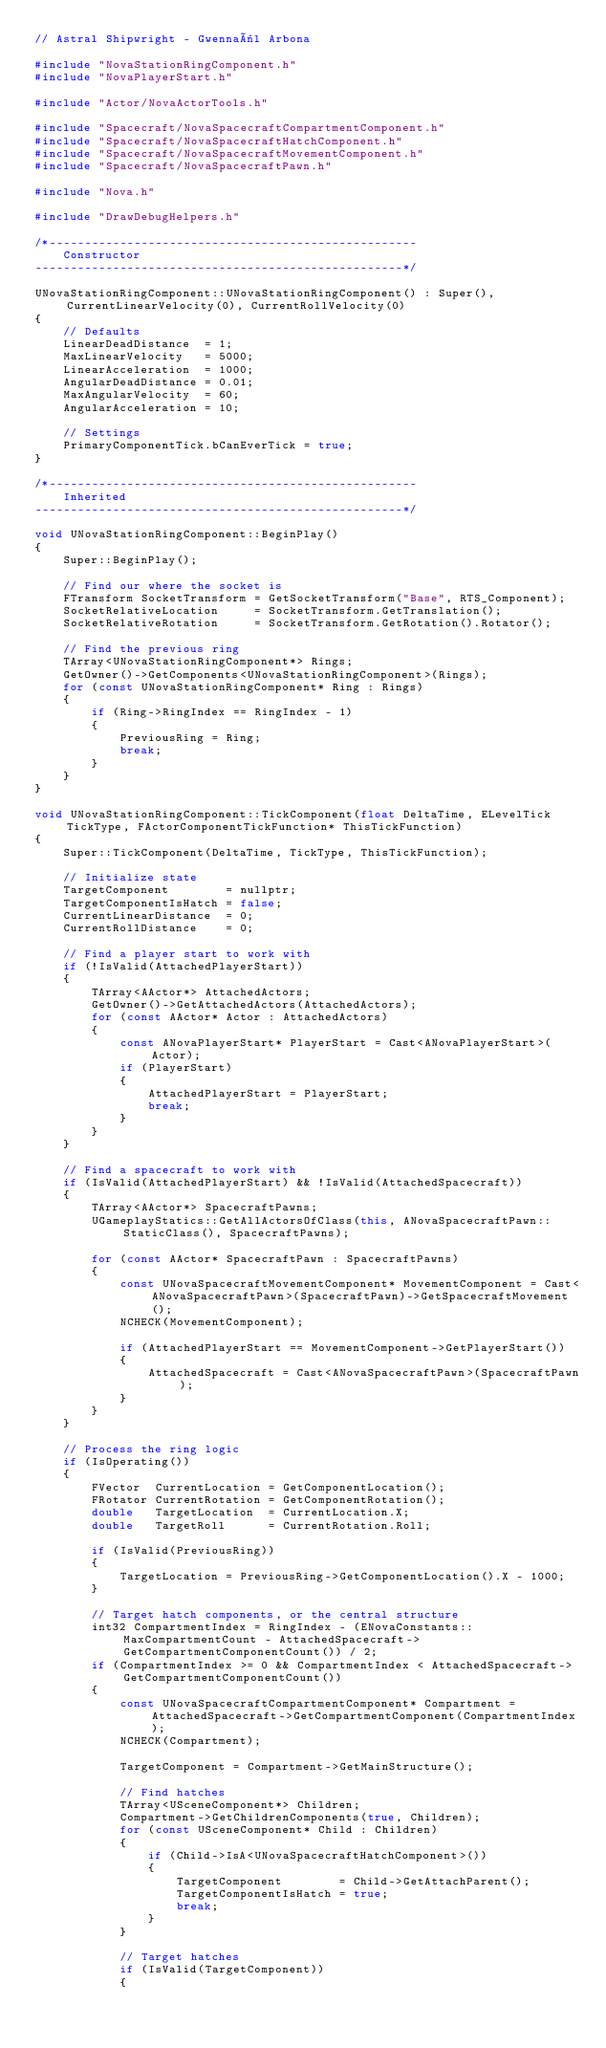Convert code to text. <code><loc_0><loc_0><loc_500><loc_500><_C++_>// Astral Shipwright - Gwennaël Arbona

#include "NovaStationRingComponent.h"
#include "NovaPlayerStart.h"

#include "Actor/NovaActorTools.h"

#include "Spacecraft/NovaSpacecraftCompartmentComponent.h"
#include "Spacecraft/NovaSpacecraftHatchComponent.h"
#include "Spacecraft/NovaSpacecraftMovementComponent.h"
#include "Spacecraft/NovaSpacecraftPawn.h"

#include "Nova.h"

#include "DrawDebugHelpers.h"

/*----------------------------------------------------
    Constructor
----------------------------------------------------*/

UNovaStationRingComponent::UNovaStationRingComponent() : Super(), CurrentLinearVelocity(0), CurrentRollVelocity(0)
{
	// Defaults
	LinearDeadDistance  = 1;
	MaxLinearVelocity   = 5000;
	LinearAcceleration  = 1000;
	AngularDeadDistance = 0.01;
	MaxAngularVelocity  = 60;
	AngularAcceleration = 10;

	// Settings
	PrimaryComponentTick.bCanEverTick = true;
}

/*----------------------------------------------------
    Inherited
----------------------------------------------------*/

void UNovaStationRingComponent::BeginPlay()
{
	Super::BeginPlay();

	// Find our where the socket is
	FTransform SocketTransform = GetSocketTransform("Base", RTS_Component);
	SocketRelativeLocation     = SocketTransform.GetTranslation();
	SocketRelativeRotation     = SocketTransform.GetRotation().Rotator();

	// Find the previous ring
	TArray<UNovaStationRingComponent*> Rings;
	GetOwner()->GetComponents<UNovaStationRingComponent>(Rings);
	for (const UNovaStationRingComponent* Ring : Rings)
	{
		if (Ring->RingIndex == RingIndex - 1)
		{
			PreviousRing = Ring;
			break;
		}
	}
}

void UNovaStationRingComponent::TickComponent(float DeltaTime, ELevelTick TickType, FActorComponentTickFunction* ThisTickFunction)
{
	Super::TickComponent(DeltaTime, TickType, ThisTickFunction);

	// Initialize state
	TargetComponent        = nullptr;
	TargetComponentIsHatch = false;
	CurrentLinearDistance  = 0;
	CurrentRollDistance    = 0;

	// Find a player start to work with
	if (!IsValid(AttachedPlayerStart))
	{
		TArray<AActor*> AttachedActors;
		GetOwner()->GetAttachedActors(AttachedActors);
		for (const AActor* Actor : AttachedActors)
		{
			const ANovaPlayerStart* PlayerStart = Cast<ANovaPlayerStart>(Actor);
			if (PlayerStart)
			{
				AttachedPlayerStart = PlayerStart;
				break;
			}
		}
	}

	// Find a spacecraft to work with
	if (IsValid(AttachedPlayerStart) && !IsValid(AttachedSpacecraft))
	{
		TArray<AActor*> SpacecraftPawns;
		UGameplayStatics::GetAllActorsOfClass(this, ANovaSpacecraftPawn::StaticClass(), SpacecraftPawns);

		for (const AActor* SpacecraftPawn : SpacecraftPawns)
		{
			const UNovaSpacecraftMovementComponent* MovementComponent = Cast<ANovaSpacecraftPawn>(SpacecraftPawn)->GetSpacecraftMovement();
			NCHECK(MovementComponent);

			if (AttachedPlayerStart == MovementComponent->GetPlayerStart())
			{
				AttachedSpacecraft = Cast<ANovaSpacecraftPawn>(SpacecraftPawn);
			}
		}
	}

	// Process the ring logic
	if (IsOperating())
	{
		FVector  CurrentLocation = GetComponentLocation();
		FRotator CurrentRotation = GetComponentRotation();
		double   TargetLocation  = CurrentLocation.X;
		double   TargetRoll      = CurrentRotation.Roll;

		if (IsValid(PreviousRing))
		{
			TargetLocation = PreviousRing->GetComponentLocation().X - 1000;
		}

		// Target hatch components, or the central structure
		int32 CompartmentIndex = RingIndex - (ENovaConstants::MaxCompartmentCount - AttachedSpacecraft->GetCompartmentComponentCount()) / 2;
		if (CompartmentIndex >= 0 && CompartmentIndex < AttachedSpacecraft->GetCompartmentComponentCount())
		{
			const UNovaSpacecraftCompartmentComponent* Compartment = AttachedSpacecraft->GetCompartmentComponent(CompartmentIndex);
			NCHECK(Compartment);

			TargetComponent = Compartment->GetMainStructure();

			// Find hatches
			TArray<USceneComponent*> Children;
			Compartment->GetChildrenComponents(true, Children);
			for (const USceneComponent* Child : Children)
			{
				if (Child->IsA<UNovaSpacecraftHatchComponent>())
				{
					TargetComponent        = Child->GetAttachParent();
					TargetComponentIsHatch = true;
					break;
				}
			}

			// Target hatches
			if (IsValid(TargetComponent))
			{</code> 